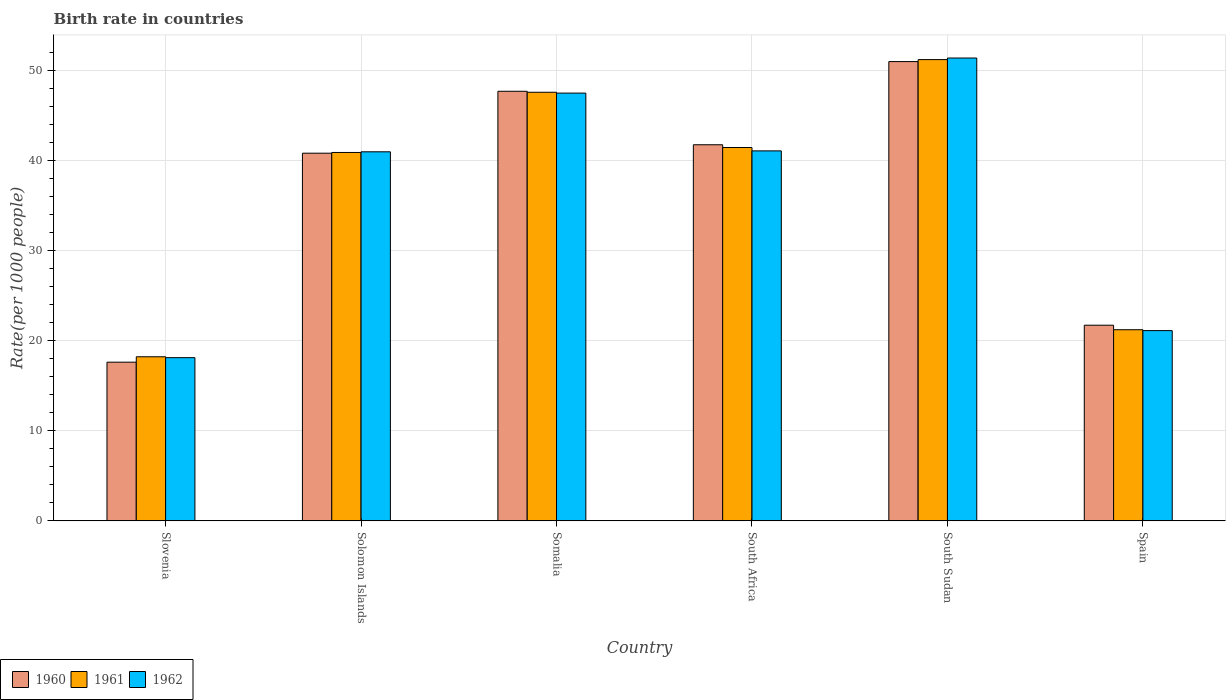How many different coloured bars are there?
Your answer should be very brief. 3. How many groups of bars are there?
Your response must be concise. 6. How many bars are there on the 4th tick from the left?
Provide a short and direct response. 3. In how many cases, is the number of bars for a given country not equal to the number of legend labels?
Make the answer very short. 0. Across all countries, what is the maximum birth rate in 1960?
Offer a terse response. 50.95. In which country was the birth rate in 1960 maximum?
Your answer should be compact. South Sudan. In which country was the birth rate in 1962 minimum?
Keep it short and to the point. Slovenia. What is the total birth rate in 1960 in the graph?
Ensure brevity in your answer.  220.4. What is the difference between the birth rate in 1962 in Solomon Islands and that in Somalia?
Offer a terse response. -6.51. What is the difference between the birth rate in 1960 in Somalia and the birth rate in 1961 in Slovenia?
Give a very brief answer. 29.45. What is the average birth rate in 1961 per country?
Provide a short and direct response. 36.73. What is the difference between the birth rate of/in 1962 and birth rate of/in 1961 in Spain?
Your response must be concise. -0.1. What is the ratio of the birth rate in 1962 in South Sudan to that in Spain?
Your answer should be very brief. 2.43. What is the difference between the highest and the second highest birth rate in 1961?
Your answer should be very brief. -9.75. What is the difference between the highest and the lowest birth rate in 1962?
Ensure brevity in your answer.  33.24. In how many countries, is the birth rate in 1962 greater than the average birth rate in 1962 taken over all countries?
Your response must be concise. 4. What does the 3rd bar from the left in Solomon Islands represents?
Offer a very short reply. 1962. Are all the bars in the graph horizontal?
Ensure brevity in your answer.  No. How many countries are there in the graph?
Make the answer very short. 6. What is the difference between two consecutive major ticks on the Y-axis?
Make the answer very short. 10. Does the graph contain any zero values?
Provide a succinct answer. No. Where does the legend appear in the graph?
Make the answer very short. Bottom left. How many legend labels are there?
Your answer should be compact. 3. How are the legend labels stacked?
Make the answer very short. Horizontal. What is the title of the graph?
Make the answer very short. Birth rate in countries. What is the label or title of the X-axis?
Offer a very short reply. Country. What is the label or title of the Y-axis?
Offer a very short reply. Rate(per 1000 people). What is the Rate(per 1000 people) in 1960 in Slovenia?
Make the answer very short. 17.6. What is the Rate(per 1000 people) of 1962 in Slovenia?
Provide a short and direct response. 18.1. What is the Rate(per 1000 people) in 1960 in Solomon Islands?
Your answer should be very brief. 40.78. What is the Rate(per 1000 people) of 1961 in Solomon Islands?
Offer a terse response. 40.86. What is the Rate(per 1000 people) in 1962 in Solomon Islands?
Make the answer very short. 40.94. What is the Rate(per 1000 people) in 1960 in Somalia?
Ensure brevity in your answer.  47.65. What is the Rate(per 1000 people) in 1961 in Somalia?
Your answer should be very brief. 47.54. What is the Rate(per 1000 people) in 1962 in Somalia?
Your response must be concise. 47.45. What is the Rate(per 1000 people) in 1960 in South Africa?
Your response must be concise. 41.72. What is the Rate(per 1000 people) of 1961 in South Africa?
Make the answer very short. 41.41. What is the Rate(per 1000 people) of 1962 in South Africa?
Your answer should be compact. 41.04. What is the Rate(per 1000 people) in 1960 in South Sudan?
Provide a short and direct response. 50.95. What is the Rate(per 1000 people) of 1961 in South Sudan?
Your answer should be very brief. 51.16. What is the Rate(per 1000 people) of 1962 in South Sudan?
Your response must be concise. 51.34. What is the Rate(per 1000 people) of 1960 in Spain?
Your answer should be very brief. 21.7. What is the Rate(per 1000 people) of 1961 in Spain?
Your answer should be very brief. 21.2. What is the Rate(per 1000 people) in 1962 in Spain?
Offer a terse response. 21.1. Across all countries, what is the maximum Rate(per 1000 people) of 1960?
Your answer should be very brief. 50.95. Across all countries, what is the maximum Rate(per 1000 people) of 1961?
Ensure brevity in your answer.  51.16. Across all countries, what is the maximum Rate(per 1000 people) of 1962?
Make the answer very short. 51.34. Across all countries, what is the minimum Rate(per 1000 people) in 1962?
Your answer should be very brief. 18.1. What is the total Rate(per 1000 people) of 1960 in the graph?
Your response must be concise. 220.4. What is the total Rate(per 1000 people) in 1961 in the graph?
Your answer should be compact. 220.38. What is the total Rate(per 1000 people) of 1962 in the graph?
Your answer should be very brief. 219.97. What is the difference between the Rate(per 1000 people) of 1960 in Slovenia and that in Solomon Islands?
Your answer should be very brief. -23.18. What is the difference between the Rate(per 1000 people) in 1961 in Slovenia and that in Solomon Islands?
Your response must be concise. -22.66. What is the difference between the Rate(per 1000 people) of 1962 in Slovenia and that in Solomon Islands?
Your answer should be very brief. -22.84. What is the difference between the Rate(per 1000 people) of 1960 in Slovenia and that in Somalia?
Offer a very short reply. -30.05. What is the difference between the Rate(per 1000 people) of 1961 in Slovenia and that in Somalia?
Ensure brevity in your answer.  -29.34. What is the difference between the Rate(per 1000 people) in 1962 in Slovenia and that in Somalia?
Give a very brief answer. -29.35. What is the difference between the Rate(per 1000 people) in 1960 in Slovenia and that in South Africa?
Your response must be concise. -24.12. What is the difference between the Rate(per 1000 people) of 1961 in Slovenia and that in South Africa?
Keep it short and to the point. -23.21. What is the difference between the Rate(per 1000 people) of 1962 in Slovenia and that in South Africa?
Provide a succinct answer. -22.94. What is the difference between the Rate(per 1000 people) of 1960 in Slovenia and that in South Sudan?
Your answer should be compact. -33.34. What is the difference between the Rate(per 1000 people) in 1961 in Slovenia and that in South Sudan?
Your answer should be compact. -32.97. What is the difference between the Rate(per 1000 people) in 1962 in Slovenia and that in South Sudan?
Give a very brief answer. -33.24. What is the difference between the Rate(per 1000 people) in 1962 in Slovenia and that in Spain?
Your answer should be very brief. -3. What is the difference between the Rate(per 1000 people) of 1960 in Solomon Islands and that in Somalia?
Make the answer very short. -6.87. What is the difference between the Rate(per 1000 people) of 1961 in Solomon Islands and that in Somalia?
Your answer should be compact. -6.68. What is the difference between the Rate(per 1000 people) of 1962 in Solomon Islands and that in Somalia?
Provide a short and direct response. -6.51. What is the difference between the Rate(per 1000 people) in 1960 in Solomon Islands and that in South Africa?
Your answer should be very brief. -0.94. What is the difference between the Rate(per 1000 people) of 1961 in Solomon Islands and that in South Africa?
Your response must be concise. -0.55. What is the difference between the Rate(per 1000 people) of 1962 in Solomon Islands and that in South Africa?
Make the answer very short. -0.1. What is the difference between the Rate(per 1000 people) in 1960 in Solomon Islands and that in South Sudan?
Give a very brief answer. -10.16. What is the difference between the Rate(per 1000 people) of 1961 in Solomon Islands and that in South Sudan?
Provide a short and direct response. -10.3. What is the difference between the Rate(per 1000 people) in 1962 in Solomon Islands and that in South Sudan?
Offer a terse response. -10.4. What is the difference between the Rate(per 1000 people) in 1960 in Solomon Islands and that in Spain?
Your answer should be very brief. 19.08. What is the difference between the Rate(per 1000 people) in 1961 in Solomon Islands and that in Spain?
Give a very brief answer. 19.66. What is the difference between the Rate(per 1000 people) of 1962 in Solomon Islands and that in Spain?
Give a very brief answer. 19.84. What is the difference between the Rate(per 1000 people) of 1960 in Somalia and that in South Africa?
Give a very brief answer. 5.93. What is the difference between the Rate(per 1000 people) of 1961 in Somalia and that in South Africa?
Provide a short and direct response. 6.13. What is the difference between the Rate(per 1000 people) of 1962 in Somalia and that in South Africa?
Give a very brief answer. 6.41. What is the difference between the Rate(per 1000 people) in 1960 in Somalia and that in South Sudan?
Give a very brief answer. -3.29. What is the difference between the Rate(per 1000 people) of 1961 in Somalia and that in South Sudan?
Give a very brief answer. -3.62. What is the difference between the Rate(per 1000 people) of 1962 in Somalia and that in South Sudan?
Your response must be concise. -3.89. What is the difference between the Rate(per 1000 people) in 1960 in Somalia and that in Spain?
Offer a very short reply. 25.95. What is the difference between the Rate(per 1000 people) of 1961 in Somalia and that in Spain?
Provide a short and direct response. 26.34. What is the difference between the Rate(per 1000 people) of 1962 in Somalia and that in Spain?
Provide a succinct answer. 26.35. What is the difference between the Rate(per 1000 people) in 1960 in South Africa and that in South Sudan?
Your response must be concise. -9.23. What is the difference between the Rate(per 1000 people) in 1961 in South Africa and that in South Sudan?
Your answer should be very brief. -9.75. What is the difference between the Rate(per 1000 people) of 1962 in South Africa and that in South Sudan?
Provide a short and direct response. -10.3. What is the difference between the Rate(per 1000 people) of 1960 in South Africa and that in Spain?
Your answer should be compact. 20.02. What is the difference between the Rate(per 1000 people) of 1961 in South Africa and that in Spain?
Your response must be concise. 20.21. What is the difference between the Rate(per 1000 people) in 1962 in South Africa and that in Spain?
Provide a short and direct response. 19.94. What is the difference between the Rate(per 1000 people) in 1960 in South Sudan and that in Spain?
Give a very brief answer. 29.25. What is the difference between the Rate(per 1000 people) of 1961 in South Sudan and that in Spain?
Offer a terse response. 29.96. What is the difference between the Rate(per 1000 people) of 1962 in South Sudan and that in Spain?
Provide a short and direct response. 30.24. What is the difference between the Rate(per 1000 people) of 1960 in Slovenia and the Rate(per 1000 people) of 1961 in Solomon Islands?
Your answer should be very brief. -23.26. What is the difference between the Rate(per 1000 people) in 1960 in Slovenia and the Rate(per 1000 people) in 1962 in Solomon Islands?
Give a very brief answer. -23.34. What is the difference between the Rate(per 1000 people) of 1961 in Slovenia and the Rate(per 1000 people) of 1962 in Solomon Islands?
Your response must be concise. -22.74. What is the difference between the Rate(per 1000 people) in 1960 in Slovenia and the Rate(per 1000 people) in 1961 in Somalia?
Offer a very short reply. -29.94. What is the difference between the Rate(per 1000 people) in 1960 in Slovenia and the Rate(per 1000 people) in 1962 in Somalia?
Provide a short and direct response. -29.85. What is the difference between the Rate(per 1000 people) of 1961 in Slovenia and the Rate(per 1000 people) of 1962 in Somalia?
Offer a very short reply. -29.25. What is the difference between the Rate(per 1000 people) in 1960 in Slovenia and the Rate(per 1000 people) in 1961 in South Africa?
Ensure brevity in your answer.  -23.81. What is the difference between the Rate(per 1000 people) in 1960 in Slovenia and the Rate(per 1000 people) in 1962 in South Africa?
Offer a very short reply. -23.44. What is the difference between the Rate(per 1000 people) of 1961 in Slovenia and the Rate(per 1000 people) of 1962 in South Africa?
Give a very brief answer. -22.84. What is the difference between the Rate(per 1000 people) of 1960 in Slovenia and the Rate(per 1000 people) of 1961 in South Sudan?
Offer a terse response. -33.56. What is the difference between the Rate(per 1000 people) in 1960 in Slovenia and the Rate(per 1000 people) in 1962 in South Sudan?
Ensure brevity in your answer.  -33.74. What is the difference between the Rate(per 1000 people) of 1961 in Slovenia and the Rate(per 1000 people) of 1962 in South Sudan?
Ensure brevity in your answer.  -33.14. What is the difference between the Rate(per 1000 people) of 1960 in Slovenia and the Rate(per 1000 people) of 1961 in Spain?
Your response must be concise. -3.6. What is the difference between the Rate(per 1000 people) of 1960 in Slovenia and the Rate(per 1000 people) of 1962 in Spain?
Offer a terse response. -3.5. What is the difference between the Rate(per 1000 people) in 1961 in Slovenia and the Rate(per 1000 people) in 1962 in Spain?
Offer a very short reply. -2.9. What is the difference between the Rate(per 1000 people) in 1960 in Solomon Islands and the Rate(per 1000 people) in 1961 in Somalia?
Your answer should be compact. -6.76. What is the difference between the Rate(per 1000 people) in 1960 in Solomon Islands and the Rate(per 1000 people) in 1962 in Somalia?
Your answer should be very brief. -6.67. What is the difference between the Rate(per 1000 people) in 1961 in Solomon Islands and the Rate(per 1000 people) in 1962 in Somalia?
Provide a succinct answer. -6.58. What is the difference between the Rate(per 1000 people) in 1960 in Solomon Islands and the Rate(per 1000 people) in 1961 in South Africa?
Keep it short and to the point. -0.63. What is the difference between the Rate(per 1000 people) in 1960 in Solomon Islands and the Rate(per 1000 people) in 1962 in South Africa?
Make the answer very short. -0.26. What is the difference between the Rate(per 1000 people) of 1961 in Solomon Islands and the Rate(per 1000 people) of 1962 in South Africa?
Provide a succinct answer. -0.17. What is the difference between the Rate(per 1000 people) in 1960 in Solomon Islands and the Rate(per 1000 people) in 1961 in South Sudan?
Provide a short and direct response. -10.38. What is the difference between the Rate(per 1000 people) of 1960 in Solomon Islands and the Rate(per 1000 people) of 1962 in South Sudan?
Offer a terse response. -10.56. What is the difference between the Rate(per 1000 people) of 1961 in Solomon Islands and the Rate(per 1000 people) of 1962 in South Sudan?
Your answer should be compact. -10.48. What is the difference between the Rate(per 1000 people) of 1960 in Solomon Islands and the Rate(per 1000 people) of 1961 in Spain?
Make the answer very short. 19.58. What is the difference between the Rate(per 1000 people) in 1960 in Solomon Islands and the Rate(per 1000 people) in 1962 in Spain?
Provide a succinct answer. 19.68. What is the difference between the Rate(per 1000 people) in 1961 in Solomon Islands and the Rate(per 1000 people) in 1962 in Spain?
Your answer should be compact. 19.76. What is the difference between the Rate(per 1000 people) of 1960 in Somalia and the Rate(per 1000 people) of 1961 in South Africa?
Ensure brevity in your answer.  6.24. What is the difference between the Rate(per 1000 people) in 1960 in Somalia and the Rate(per 1000 people) in 1962 in South Africa?
Make the answer very short. 6.61. What is the difference between the Rate(per 1000 people) of 1961 in Somalia and the Rate(per 1000 people) of 1962 in South Africa?
Your answer should be very brief. 6.5. What is the difference between the Rate(per 1000 people) of 1960 in Somalia and the Rate(per 1000 people) of 1961 in South Sudan?
Offer a terse response. -3.51. What is the difference between the Rate(per 1000 people) of 1960 in Somalia and the Rate(per 1000 people) of 1962 in South Sudan?
Make the answer very short. -3.69. What is the difference between the Rate(per 1000 people) in 1961 in Somalia and the Rate(per 1000 people) in 1962 in South Sudan?
Provide a succinct answer. -3.8. What is the difference between the Rate(per 1000 people) in 1960 in Somalia and the Rate(per 1000 people) in 1961 in Spain?
Make the answer very short. 26.45. What is the difference between the Rate(per 1000 people) in 1960 in Somalia and the Rate(per 1000 people) in 1962 in Spain?
Your answer should be compact. 26.55. What is the difference between the Rate(per 1000 people) of 1961 in Somalia and the Rate(per 1000 people) of 1962 in Spain?
Your answer should be very brief. 26.44. What is the difference between the Rate(per 1000 people) in 1960 in South Africa and the Rate(per 1000 people) in 1961 in South Sudan?
Your response must be concise. -9.45. What is the difference between the Rate(per 1000 people) of 1960 in South Africa and the Rate(per 1000 people) of 1962 in South Sudan?
Keep it short and to the point. -9.62. What is the difference between the Rate(per 1000 people) of 1961 in South Africa and the Rate(per 1000 people) of 1962 in South Sudan?
Provide a succinct answer. -9.93. What is the difference between the Rate(per 1000 people) of 1960 in South Africa and the Rate(per 1000 people) of 1961 in Spain?
Make the answer very short. 20.52. What is the difference between the Rate(per 1000 people) in 1960 in South Africa and the Rate(per 1000 people) in 1962 in Spain?
Provide a succinct answer. 20.62. What is the difference between the Rate(per 1000 people) in 1961 in South Africa and the Rate(per 1000 people) in 1962 in Spain?
Offer a very short reply. 20.31. What is the difference between the Rate(per 1000 people) of 1960 in South Sudan and the Rate(per 1000 people) of 1961 in Spain?
Your answer should be very brief. 29.75. What is the difference between the Rate(per 1000 people) of 1960 in South Sudan and the Rate(per 1000 people) of 1962 in Spain?
Your response must be concise. 29.84. What is the difference between the Rate(per 1000 people) of 1961 in South Sudan and the Rate(per 1000 people) of 1962 in Spain?
Offer a terse response. 30.07. What is the average Rate(per 1000 people) of 1960 per country?
Offer a very short reply. 36.73. What is the average Rate(per 1000 people) of 1961 per country?
Make the answer very short. 36.73. What is the average Rate(per 1000 people) of 1962 per country?
Offer a terse response. 36.66. What is the difference between the Rate(per 1000 people) of 1960 and Rate(per 1000 people) of 1962 in Slovenia?
Your answer should be very brief. -0.5. What is the difference between the Rate(per 1000 people) of 1960 and Rate(per 1000 people) of 1961 in Solomon Islands?
Provide a succinct answer. -0.08. What is the difference between the Rate(per 1000 people) in 1960 and Rate(per 1000 people) in 1962 in Solomon Islands?
Your response must be concise. -0.15. What is the difference between the Rate(per 1000 people) of 1961 and Rate(per 1000 people) of 1962 in Solomon Islands?
Your response must be concise. -0.07. What is the difference between the Rate(per 1000 people) in 1960 and Rate(per 1000 people) in 1961 in Somalia?
Provide a short and direct response. 0.11. What is the difference between the Rate(per 1000 people) in 1960 and Rate(per 1000 people) in 1962 in Somalia?
Provide a short and direct response. 0.2. What is the difference between the Rate(per 1000 people) in 1961 and Rate(per 1000 people) in 1962 in Somalia?
Your response must be concise. 0.1. What is the difference between the Rate(per 1000 people) in 1960 and Rate(per 1000 people) in 1961 in South Africa?
Keep it short and to the point. 0.31. What is the difference between the Rate(per 1000 people) of 1960 and Rate(per 1000 people) of 1962 in South Africa?
Your response must be concise. 0.68. What is the difference between the Rate(per 1000 people) in 1961 and Rate(per 1000 people) in 1962 in South Africa?
Ensure brevity in your answer.  0.37. What is the difference between the Rate(per 1000 people) of 1960 and Rate(per 1000 people) of 1961 in South Sudan?
Offer a terse response. -0.22. What is the difference between the Rate(per 1000 people) of 1960 and Rate(per 1000 people) of 1962 in South Sudan?
Ensure brevity in your answer.  -0.4. What is the difference between the Rate(per 1000 people) in 1961 and Rate(per 1000 people) in 1962 in South Sudan?
Your response must be concise. -0.18. What is the difference between the Rate(per 1000 people) in 1961 and Rate(per 1000 people) in 1962 in Spain?
Your response must be concise. 0.1. What is the ratio of the Rate(per 1000 people) of 1960 in Slovenia to that in Solomon Islands?
Provide a succinct answer. 0.43. What is the ratio of the Rate(per 1000 people) in 1961 in Slovenia to that in Solomon Islands?
Provide a short and direct response. 0.45. What is the ratio of the Rate(per 1000 people) in 1962 in Slovenia to that in Solomon Islands?
Keep it short and to the point. 0.44. What is the ratio of the Rate(per 1000 people) of 1960 in Slovenia to that in Somalia?
Offer a very short reply. 0.37. What is the ratio of the Rate(per 1000 people) in 1961 in Slovenia to that in Somalia?
Ensure brevity in your answer.  0.38. What is the ratio of the Rate(per 1000 people) of 1962 in Slovenia to that in Somalia?
Offer a terse response. 0.38. What is the ratio of the Rate(per 1000 people) of 1960 in Slovenia to that in South Africa?
Your answer should be compact. 0.42. What is the ratio of the Rate(per 1000 people) of 1961 in Slovenia to that in South Africa?
Keep it short and to the point. 0.44. What is the ratio of the Rate(per 1000 people) of 1962 in Slovenia to that in South Africa?
Keep it short and to the point. 0.44. What is the ratio of the Rate(per 1000 people) of 1960 in Slovenia to that in South Sudan?
Offer a terse response. 0.35. What is the ratio of the Rate(per 1000 people) of 1961 in Slovenia to that in South Sudan?
Your answer should be compact. 0.36. What is the ratio of the Rate(per 1000 people) in 1962 in Slovenia to that in South Sudan?
Make the answer very short. 0.35. What is the ratio of the Rate(per 1000 people) of 1960 in Slovenia to that in Spain?
Your answer should be compact. 0.81. What is the ratio of the Rate(per 1000 people) of 1961 in Slovenia to that in Spain?
Give a very brief answer. 0.86. What is the ratio of the Rate(per 1000 people) of 1962 in Slovenia to that in Spain?
Ensure brevity in your answer.  0.86. What is the ratio of the Rate(per 1000 people) in 1960 in Solomon Islands to that in Somalia?
Your response must be concise. 0.86. What is the ratio of the Rate(per 1000 people) in 1961 in Solomon Islands to that in Somalia?
Ensure brevity in your answer.  0.86. What is the ratio of the Rate(per 1000 people) in 1962 in Solomon Islands to that in Somalia?
Offer a terse response. 0.86. What is the ratio of the Rate(per 1000 people) in 1960 in Solomon Islands to that in South Africa?
Provide a short and direct response. 0.98. What is the ratio of the Rate(per 1000 people) of 1961 in Solomon Islands to that in South Africa?
Your answer should be compact. 0.99. What is the ratio of the Rate(per 1000 people) in 1962 in Solomon Islands to that in South Africa?
Ensure brevity in your answer.  1. What is the ratio of the Rate(per 1000 people) of 1960 in Solomon Islands to that in South Sudan?
Make the answer very short. 0.8. What is the ratio of the Rate(per 1000 people) of 1961 in Solomon Islands to that in South Sudan?
Your response must be concise. 0.8. What is the ratio of the Rate(per 1000 people) in 1962 in Solomon Islands to that in South Sudan?
Ensure brevity in your answer.  0.8. What is the ratio of the Rate(per 1000 people) in 1960 in Solomon Islands to that in Spain?
Your answer should be compact. 1.88. What is the ratio of the Rate(per 1000 people) in 1961 in Solomon Islands to that in Spain?
Ensure brevity in your answer.  1.93. What is the ratio of the Rate(per 1000 people) of 1962 in Solomon Islands to that in Spain?
Provide a succinct answer. 1.94. What is the ratio of the Rate(per 1000 people) in 1960 in Somalia to that in South Africa?
Offer a terse response. 1.14. What is the ratio of the Rate(per 1000 people) of 1961 in Somalia to that in South Africa?
Keep it short and to the point. 1.15. What is the ratio of the Rate(per 1000 people) in 1962 in Somalia to that in South Africa?
Make the answer very short. 1.16. What is the ratio of the Rate(per 1000 people) of 1960 in Somalia to that in South Sudan?
Provide a short and direct response. 0.94. What is the ratio of the Rate(per 1000 people) in 1961 in Somalia to that in South Sudan?
Your answer should be very brief. 0.93. What is the ratio of the Rate(per 1000 people) in 1962 in Somalia to that in South Sudan?
Offer a terse response. 0.92. What is the ratio of the Rate(per 1000 people) in 1960 in Somalia to that in Spain?
Make the answer very short. 2.2. What is the ratio of the Rate(per 1000 people) in 1961 in Somalia to that in Spain?
Provide a short and direct response. 2.24. What is the ratio of the Rate(per 1000 people) in 1962 in Somalia to that in Spain?
Your response must be concise. 2.25. What is the ratio of the Rate(per 1000 people) in 1960 in South Africa to that in South Sudan?
Provide a short and direct response. 0.82. What is the ratio of the Rate(per 1000 people) of 1961 in South Africa to that in South Sudan?
Provide a succinct answer. 0.81. What is the ratio of the Rate(per 1000 people) of 1962 in South Africa to that in South Sudan?
Offer a terse response. 0.8. What is the ratio of the Rate(per 1000 people) in 1960 in South Africa to that in Spain?
Your answer should be compact. 1.92. What is the ratio of the Rate(per 1000 people) of 1961 in South Africa to that in Spain?
Give a very brief answer. 1.95. What is the ratio of the Rate(per 1000 people) of 1962 in South Africa to that in Spain?
Your response must be concise. 1.95. What is the ratio of the Rate(per 1000 people) of 1960 in South Sudan to that in Spain?
Your answer should be compact. 2.35. What is the ratio of the Rate(per 1000 people) of 1961 in South Sudan to that in Spain?
Offer a terse response. 2.41. What is the ratio of the Rate(per 1000 people) of 1962 in South Sudan to that in Spain?
Ensure brevity in your answer.  2.43. What is the difference between the highest and the second highest Rate(per 1000 people) of 1960?
Ensure brevity in your answer.  3.29. What is the difference between the highest and the second highest Rate(per 1000 people) in 1961?
Offer a very short reply. 3.62. What is the difference between the highest and the second highest Rate(per 1000 people) of 1962?
Offer a terse response. 3.89. What is the difference between the highest and the lowest Rate(per 1000 people) in 1960?
Your response must be concise. 33.34. What is the difference between the highest and the lowest Rate(per 1000 people) of 1961?
Your answer should be compact. 32.97. What is the difference between the highest and the lowest Rate(per 1000 people) in 1962?
Your answer should be compact. 33.24. 